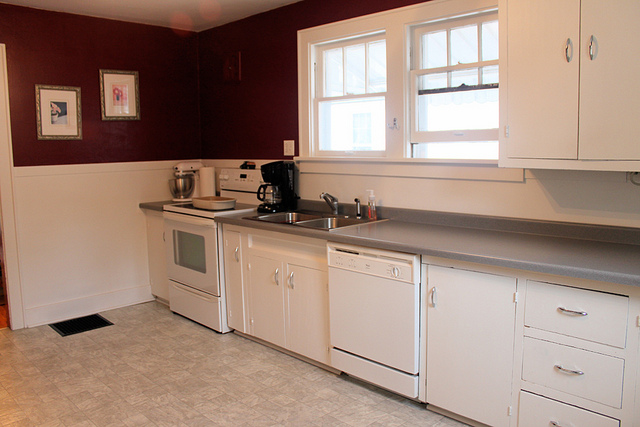Can you spot any wall sockets? Yes, there is a wall socket visible, which is located to the right of the mixer and above the countertop. 